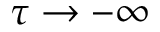Convert formula to latex. <formula><loc_0><loc_0><loc_500><loc_500>\tau \to - \infty</formula> 